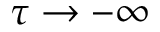Convert formula to latex. <formula><loc_0><loc_0><loc_500><loc_500>\tau \to - \infty</formula> 